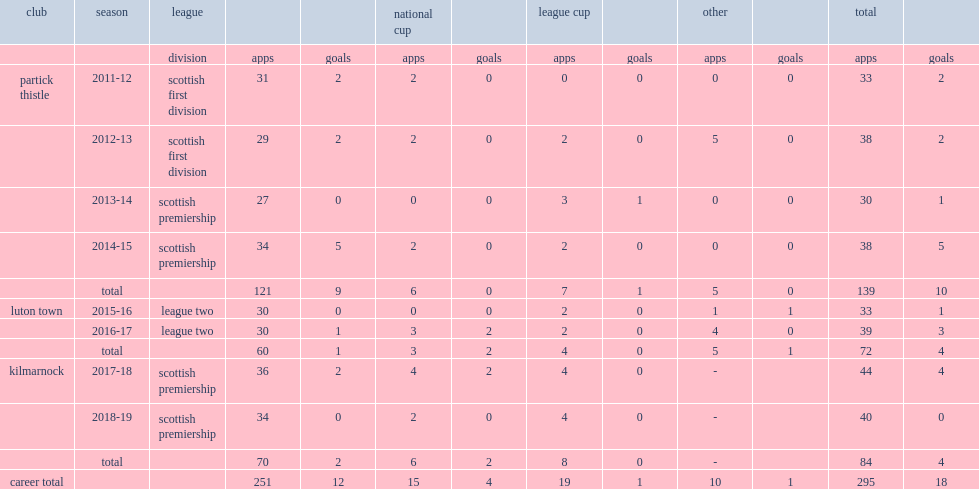What was the number of appearances made by stephen o'donnell for the partick thistle club totally? 139.0. 